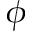Convert formula to latex. <formula><loc_0><loc_0><loc_500><loc_500>\phi</formula> 